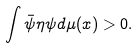<formula> <loc_0><loc_0><loc_500><loc_500>\int \bar { \psi } { \eta } \psi d \mu ( x ) > 0 .</formula> 